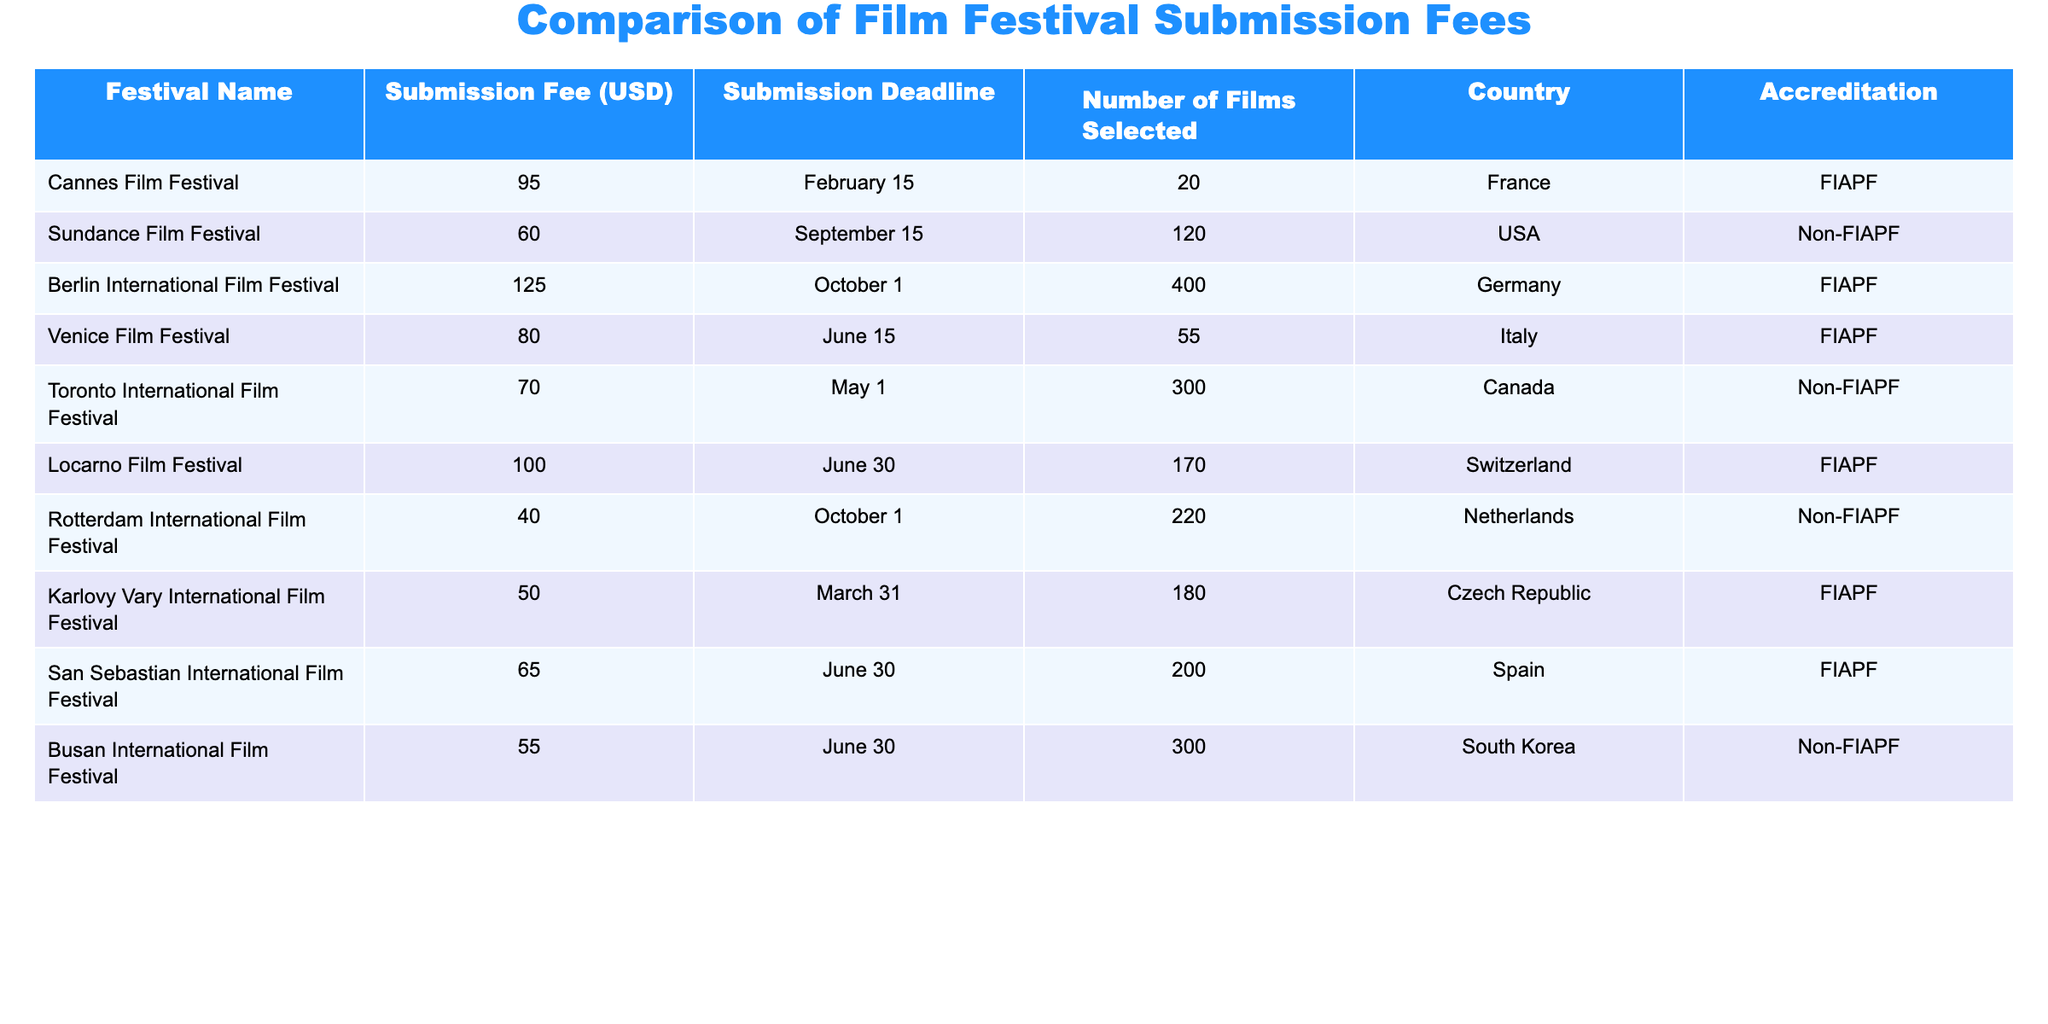What is the submission fee for the Venice Film Festival? The submission fee for the Venice Film Festival is listed directly in the table, specifically identified under "Submission Fee (USD)" for that festival's row.
Answer: 80 Which festival has the highest submission fee? By examining the "Submission Fee (USD)" column, the Berlin International Film Festival has the highest submission fee at 125 USD.
Answer: 125 How many films were selected in total across all festivals? To find the total selected films, sum the values from the "Number of Films Selected" column: 20 + 120 + 400 + 55 + 300 + 170 + 220 + 180 + 200 + 300 = 1965.
Answer: 1965 Is the San Sebastian International Film Festival accredited by FIAPF? The accreditation for the San Sebastian International Film Festival is listed in the "Accreditation" column, which shows that it is indeed accredited by FIAPF.
Answer: Yes Which festival has a lower submission fee, the Sundance Film Festival or the Busan International Film Festival? By comparing the "Submission Fee (USD)" values for both festivals, Sundance is 60 USD while Busan is 55 USD, showing that Busan has the lower submission fee.
Answer: Busan International Film Festival What is the average submission fee of festivals accredited by FIAPF? To find the average, first identify the submission fees for FIAPF accredited festivals: 95 (Cannes) + 125 (Berlin) + 80 (Venice) + 100 (Locarno) + 50 (Karlovy Vary) + 65 (San Sebastian) = 515, and then divide by the number of festivals (6): 515/6 = 85.83.
Answer: 85.83 Are more films selected at the Toronto International Film Festival than at the Karlovy Vary International Film Festival? By reviewing the "Number of Films Selected" column: Toronto has 300 selected films while Karlovy Vary has 180, which clearly indicates that more films are selected at Toronto.
Answer: Yes What is the difference in submission fees between the Cannes Film Festival and the Rotterdam International Film Festival? The submission fee for Cannes is 95 USD and for Rotterdam it is 40 USD. The difference is calculated as 95 - 40 = 55 USD.
Answer: 55 